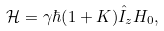Convert formula to latex. <formula><loc_0><loc_0><loc_500><loc_500>\mathcal { H } = \gamma \hbar { ( } 1 + K ) \hat { I } _ { z } H _ { 0 } ,</formula> 